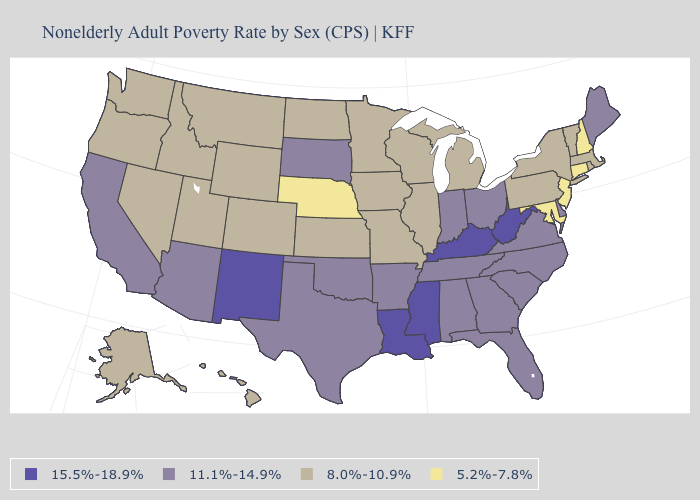What is the lowest value in the South?
Keep it brief. 5.2%-7.8%. Name the states that have a value in the range 15.5%-18.9%?
Quick response, please. Kentucky, Louisiana, Mississippi, New Mexico, West Virginia. Name the states that have a value in the range 11.1%-14.9%?
Give a very brief answer. Alabama, Arizona, Arkansas, California, Delaware, Florida, Georgia, Indiana, Maine, North Carolina, Ohio, Oklahoma, South Carolina, South Dakota, Tennessee, Texas, Virginia. What is the value of New Jersey?
Concise answer only. 5.2%-7.8%. Which states have the highest value in the USA?
Give a very brief answer. Kentucky, Louisiana, Mississippi, New Mexico, West Virginia. Name the states that have a value in the range 8.0%-10.9%?
Give a very brief answer. Alaska, Colorado, Hawaii, Idaho, Illinois, Iowa, Kansas, Massachusetts, Michigan, Minnesota, Missouri, Montana, Nevada, New York, North Dakota, Oregon, Pennsylvania, Rhode Island, Utah, Vermont, Washington, Wisconsin, Wyoming. Name the states that have a value in the range 8.0%-10.9%?
Be succinct. Alaska, Colorado, Hawaii, Idaho, Illinois, Iowa, Kansas, Massachusetts, Michigan, Minnesota, Missouri, Montana, Nevada, New York, North Dakota, Oregon, Pennsylvania, Rhode Island, Utah, Vermont, Washington, Wisconsin, Wyoming. Does the first symbol in the legend represent the smallest category?
Answer briefly. No. What is the value of North Carolina?
Give a very brief answer. 11.1%-14.9%. What is the value of Louisiana?
Concise answer only. 15.5%-18.9%. Which states have the lowest value in the USA?
Quick response, please. Connecticut, Maryland, Nebraska, New Hampshire, New Jersey. What is the value of Alaska?
Answer briefly. 8.0%-10.9%. Does the map have missing data?
Be succinct. No. Name the states that have a value in the range 5.2%-7.8%?
Quick response, please. Connecticut, Maryland, Nebraska, New Hampshire, New Jersey. What is the highest value in states that border North Carolina?
Quick response, please. 11.1%-14.9%. 